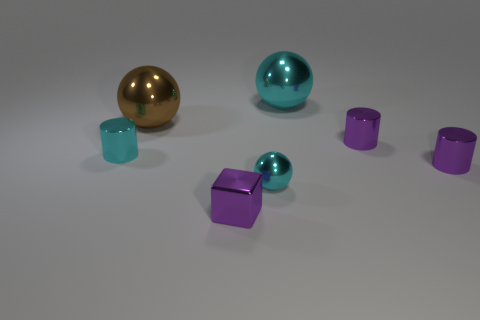Subtract all tiny spheres. How many spheres are left? 2 Subtract all yellow blocks. How many purple cylinders are left? 2 Subtract 1 balls. How many balls are left? 2 Add 2 large objects. How many objects exist? 9 Subtract all cyan cylinders. How many cylinders are left? 2 Subtract all cylinders. How many objects are left? 4 Add 3 big brown metallic balls. How many big brown metallic balls exist? 4 Subtract 1 brown balls. How many objects are left? 6 Subtract all red cubes. Subtract all gray balls. How many cubes are left? 1 Subtract all small purple things. Subtract all tiny cyan shiny spheres. How many objects are left? 3 